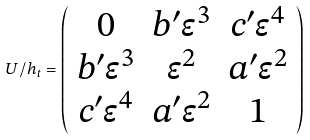Convert formula to latex. <formula><loc_0><loc_0><loc_500><loc_500>U / h _ { t } = \left ( \begin{array} { c c c } 0 & b ^ { \prime } \epsilon ^ { 3 } & c ^ { \prime } \epsilon ^ { 4 } \\ b ^ { \prime } \epsilon ^ { 3 } & \epsilon ^ { 2 } & a ^ { \prime } \epsilon ^ { 2 } \\ c ^ { \prime } \epsilon ^ { 4 } & a ^ { \prime } \epsilon ^ { 2 } & 1 \end{array} \right )</formula> 